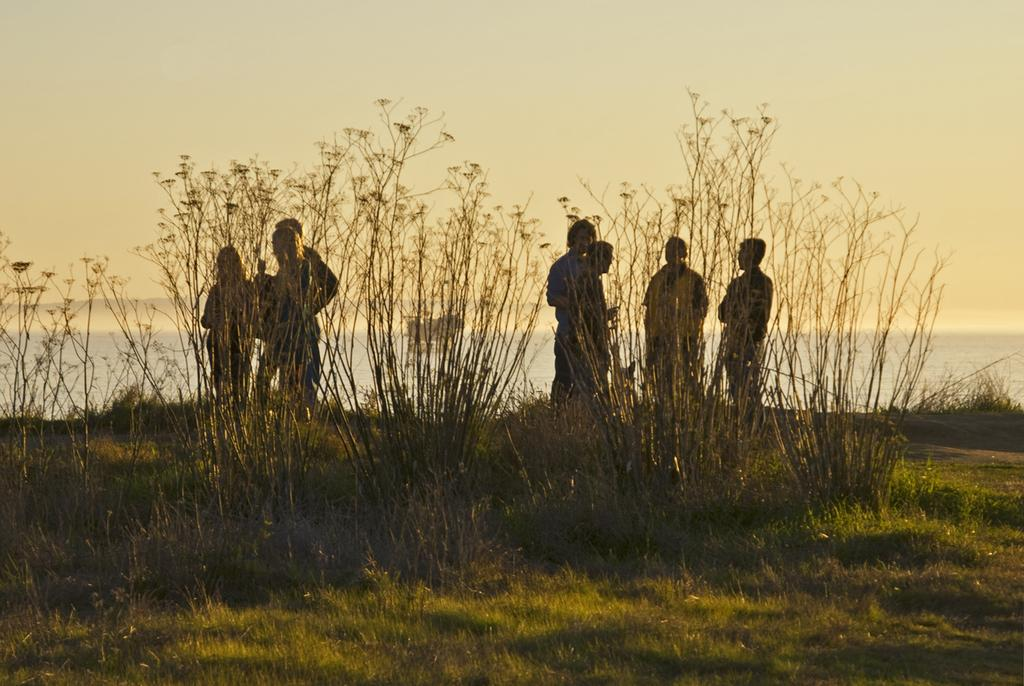What type of vegetation is at the bottom of the image? There is grass at the bottom of the image. What other types of vegetation can be seen in the image? There are plants in the image. What can be seen in the background of the image? There are people standing in the background of the image. What natural feature is visible in the image? There is a sea visible in the image. What else is visible in the image? The sky is visible in the image. What type of horn can be seen on the plough in the image? There is no plough or horn present in the image. What activity are the people participating in during the recess in the image? There is no recess or activity involving the people in the image; they are simply standing in the background. 